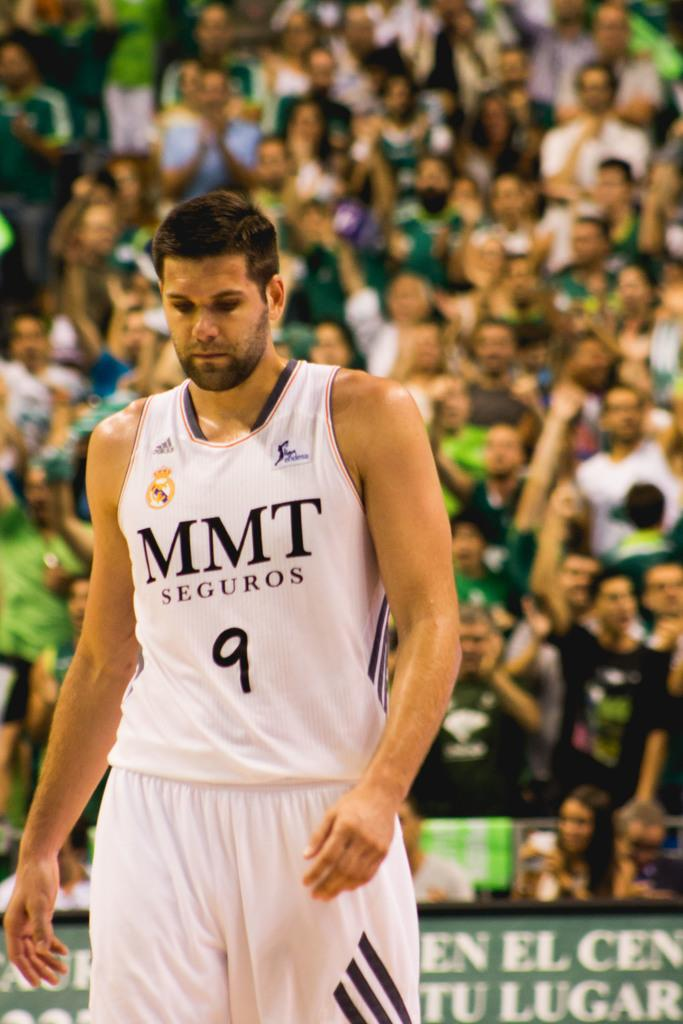<image>
Render a clear and concise summary of the photo. A basketball player wearing number nine looking down at the ground. 